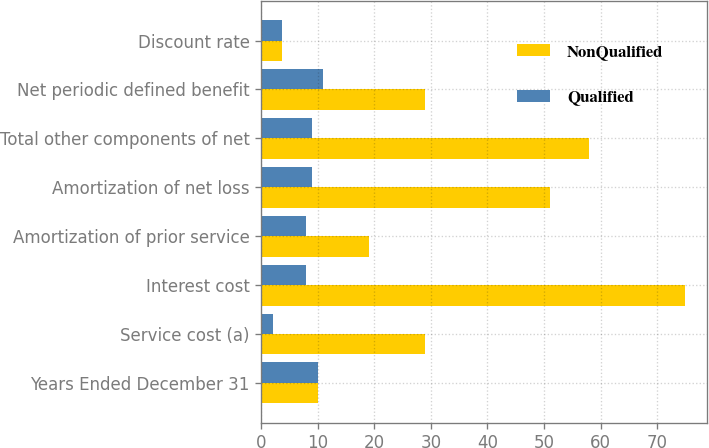Convert chart to OTSL. <chart><loc_0><loc_0><loc_500><loc_500><stacked_bar_chart><ecel><fcel>Years Ended December 31<fcel>Service cost (a)<fcel>Interest cost<fcel>Amortization of prior service<fcel>Amortization of net loss<fcel>Total other components of net<fcel>Net periodic defined benefit<fcel>Discount rate<nl><fcel>NonQualified<fcel>10<fcel>29<fcel>75<fcel>19<fcel>51<fcel>58<fcel>29<fcel>3.74<nl><fcel>Qualified<fcel>10<fcel>2<fcel>8<fcel>8<fcel>9<fcel>9<fcel>11<fcel>3.74<nl></chart> 